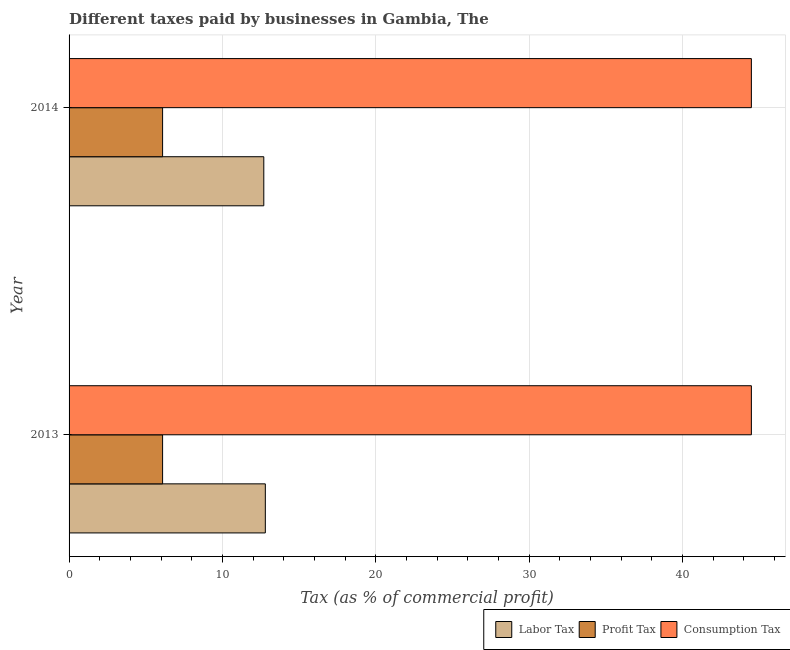How many groups of bars are there?
Your answer should be compact. 2. Are the number of bars on each tick of the Y-axis equal?
Your answer should be very brief. Yes. In how many cases, is the number of bars for a given year not equal to the number of legend labels?
Your response must be concise. 0. What is the percentage of labor tax in 2013?
Provide a succinct answer. 12.8. Across all years, what is the minimum percentage of consumption tax?
Provide a succinct answer. 44.5. In which year was the percentage of profit tax maximum?
Keep it short and to the point. 2013. What is the total percentage of profit tax in the graph?
Provide a succinct answer. 12.2. What is the difference between the percentage of consumption tax in 2013 and the percentage of labor tax in 2014?
Your answer should be very brief. 31.8. In the year 2014, what is the difference between the percentage of consumption tax and percentage of labor tax?
Give a very brief answer. 31.8. Is the percentage of consumption tax in 2013 less than that in 2014?
Ensure brevity in your answer.  No. In how many years, is the percentage of consumption tax greater than the average percentage of consumption tax taken over all years?
Provide a short and direct response. 0. What does the 3rd bar from the top in 2013 represents?
Make the answer very short. Labor Tax. What does the 1st bar from the bottom in 2014 represents?
Make the answer very short. Labor Tax. Is it the case that in every year, the sum of the percentage of labor tax and percentage of profit tax is greater than the percentage of consumption tax?
Your answer should be very brief. No. Are the values on the major ticks of X-axis written in scientific E-notation?
Ensure brevity in your answer.  No. Does the graph contain any zero values?
Ensure brevity in your answer.  No. Where does the legend appear in the graph?
Keep it short and to the point. Bottom right. How are the legend labels stacked?
Your response must be concise. Horizontal. What is the title of the graph?
Provide a succinct answer. Different taxes paid by businesses in Gambia, The. Does "Textiles and clothing" appear as one of the legend labels in the graph?
Offer a very short reply. No. What is the label or title of the X-axis?
Ensure brevity in your answer.  Tax (as % of commercial profit). What is the Tax (as % of commercial profit) in Profit Tax in 2013?
Provide a succinct answer. 6.1. What is the Tax (as % of commercial profit) in Consumption Tax in 2013?
Your answer should be compact. 44.5. What is the Tax (as % of commercial profit) of Profit Tax in 2014?
Offer a very short reply. 6.1. What is the Tax (as % of commercial profit) of Consumption Tax in 2014?
Offer a very short reply. 44.5. Across all years, what is the maximum Tax (as % of commercial profit) of Labor Tax?
Offer a very short reply. 12.8. Across all years, what is the maximum Tax (as % of commercial profit) in Consumption Tax?
Your answer should be compact. 44.5. Across all years, what is the minimum Tax (as % of commercial profit) of Labor Tax?
Your answer should be compact. 12.7. Across all years, what is the minimum Tax (as % of commercial profit) of Profit Tax?
Offer a terse response. 6.1. Across all years, what is the minimum Tax (as % of commercial profit) in Consumption Tax?
Provide a succinct answer. 44.5. What is the total Tax (as % of commercial profit) in Consumption Tax in the graph?
Offer a terse response. 89. What is the difference between the Tax (as % of commercial profit) in Consumption Tax in 2013 and that in 2014?
Your response must be concise. 0. What is the difference between the Tax (as % of commercial profit) of Labor Tax in 2013 and the Tax (as % of commercial profit) of Consumption Tax in 2014?
Give a very brief answer. -31.7. What is the difference between the Tax (as % of commercial profit) in Profit Tax in 2013 and the Tax (as % of commercial profit) in Consumption Tax in 2014?
Offer a terse response. -38.4. What is the average Tax (as % of commercial profit) of Labor Tax per year?
Give a very brief answer. 12.75. What is the average Tax (as % of commercial profit) of Profit Tax per year?
Provide a short and direct response. 6.1. What is the average Tax (as % of commercial profit) in Consumption Tax per year?
Keep it short and to the point. 44.5. In the year 2013, what is the difference between the Tax (as % of commercial profit) in Labor Tax and Tax (as % of commercial profit) in Profit Tax?
Your answer should be compact. 6.7. In the year 2013, what is the difference between the Tax (as % of commercial profit) in Labor Tax and Tax (as % of commercial profit) in Consumption Tax?
Offer a terse response. -31.7. In the year 2013, what is the difference between the Tax (as % of commercial profit) in Profit Tax and Tax (as % of commercial profit) in Consumption Tax?
Provide a succinct answer. -38.4. In the year 2014, what is the difference between the Tax (as % of commercial profit) of Labor Tax and Tax (as % of commercial profit) of Profit Tax?
Keep it short and to the point. 6.6. In the year 2014, what is the difference between the Tax (as % of commercial profit) in Labor Tax and Tax (as % of commercial profit) in Consumption Tax?
Provide a short and direct response. -31.8. In the year 2014, what is the difference between the Tax (as % of commercial profit) in Profit Tax and Tax (as % of commercial profit) in Consumption Tax?
Offer a terse response. -38.4. What is the ratio of the Tax (as % of commercial profit) in Labor Tax in 2013 to that in 2014?
Make the answer very short. 1.01. What is the ratio of the Tax (as % of commercial profit) in Profit Tax in 2013 to that in 2014?
Your answer should be compact. 1. What is the ratio of the Tax (as % of commercial profit) of Consumption Tax in 2013 to that in 2014?
Make the answer very short. 1. What is the difference between the highest and the second highest Tax (as % of commercial profit) in Labor Tax?
Offer a very short reply. 0.1. What is the difference between the highest and the second highest Tax (as % of commercial profit) of Profit Tax?
Make the answer very short. 0. 